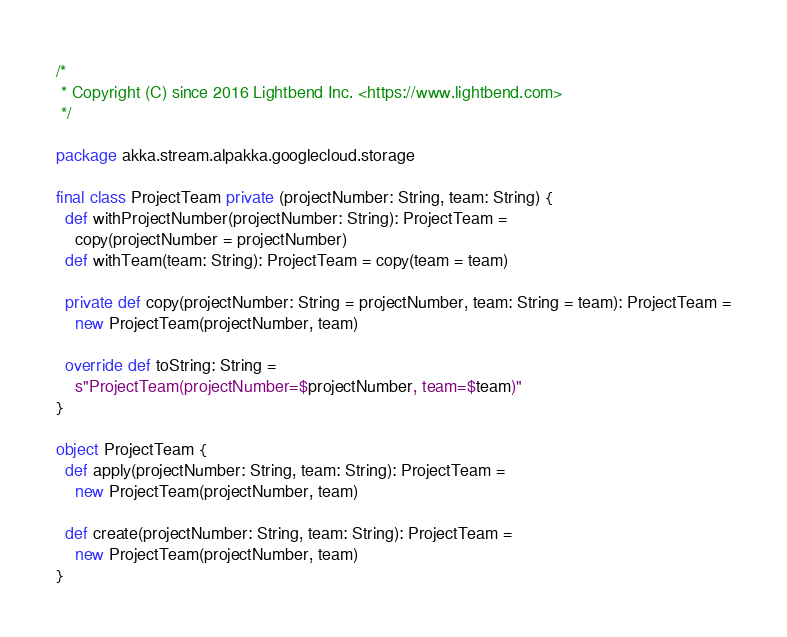<code> <loc_0><loc_0><loc_500><loc_500><_Scala_>/*
 * Copyright (C) since 2016 Lightbend Inc. <https://www.lightbend.com>
 */

package akka.stream.alpakka.googlecloud.storage

final class ProjectTeam private (projectNumber: String, team: String) {
  def withProjectNumber(projectNumber: String): ProjectTeam =
    copy(projectNumber = projectNumber)
  def withTeam(team: String): ProjectTeam = copy(team = team)

  private def copy(projectNumber: String = projectNumber, team: String = team): ProjectTeam =
    new ProjectTeam(projectNumber, team)

  override def toString: String =
    s"ProjectTeam(projectNumber=$projectNumber, team=$team)"
}

object ProjectTeam {
  def apply(projectNumber: String, team: String): ProjectTeam =
    new ProjectTeam(projectNumber, team)

  def create(projectNumber: String, team: String): ProjectTeam =
    new ProjectTeam(projectNumber, team)
}
</code> 